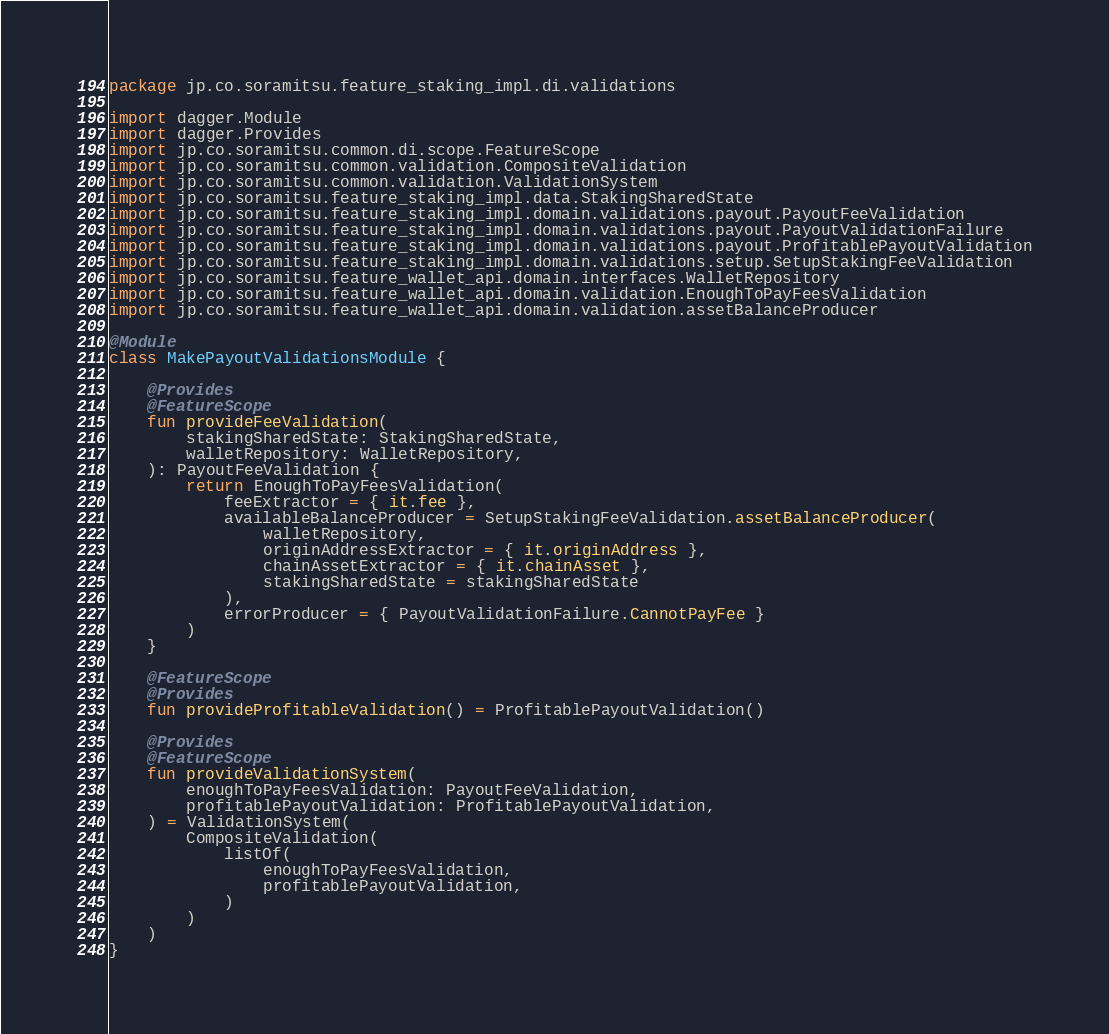Convert code to text. <code><loc_0><loc_0><loc_500><loc_500><_Kotlin_>package jp.co.soramitsu.feature_staking_impl.di.validations

import dagger.Module
import dagger.Provides
import jp.co.soramitsu.common.di.scope.FeatureScope
import jp.co.soramitsu.common.validation.CompositeValidation
import jp.co.soramitsu.common.validation.ValidationSystem
import jp.co.soramitsu.feature_staking_impl.data.StakingSharedState
import jp.co.soramitsu.feature_staking_impl.domain.validations.payout.PayoutFeeValidation
import jp.co.soramitsu.feature_staking_impl.domain.validations.payout.PayoutValidationFailure
import jp.co.soramitsu.feature_staking_impl.domain.validations.payout.ProfitablePayoutValidation
import jp.co.soramitsu.feature_staking_impl.domain.validations.setup.SetupStakingFeeValidation
import jp.co.soramitsu.feature_wallet_api.domain.interfaces.WalletRepository
import jp.co.soramitsu.feature_wallet_api.domain.validation.EnoughToPayFeesValidation
import jp.co.soramitsu.feature_wallet_api.domain.validation.assetBalanceProducer

@Module
class MakePayoutValidationsModule {

    @Provides
    @FeatureScope
    fun provideFeeValidation(
        stakingSharedState: StakingSharedState,
        walletRepository: WalletRepository,
    ): PayoutFeeValidation {
        return EnoughToPayFeesValidation(
            feeExtractor = { it.fee },
            availableBalanceProducer = SetupStakingFeeValidation.assetBalanceProducer(
                walletRepository,
                originAddressExtractor = { it.originAddress },
                chainAssetExtractor = { it.chainAsset },
                stakingSharedState = stakingSharedState
            ),
            errorProducer = { PayoutValidationFailure.CannotPayFee }
        )
    }

    @FeatureScope
    @Provides
    fun provideProfitableValidation() = ProfitablePayoutValidation()

    @Provides
    @FeatureScope
    fun provideValidationSystem(
        enoughToPayFeesValidation: PayoutFeeValidation,
        profitablePayoutValidation: ProfitablePayoutValidation,
    ) = ValidationSystem(
        CompositeValidation(
            listOf(
                enoughToPayFeesValidation,
                profitablePayoutValidation,
            )
        )
    )
}
</code> 